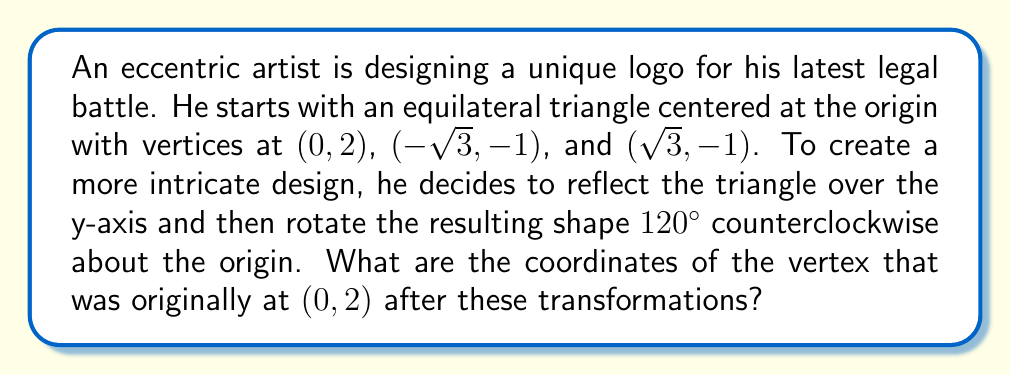Teach me how to tackle this problem. Let's approach this step-by-step:

1) First, we reflect the triangle over the y-axis:
   The point $(0, 2)$ remains unchanged as it's on the y-axis.
   $(-\sqrt{3}, -1)$ becomes $(\sqrt{3}, -1)$
   $(\sqrt{3}, -1)$ becomes $(-\sqrt{3}, -1)$

2) Now we have a new triangle with vertices at $(0, 2)$, $(\sqrt{3}, -1)$, and $(-\sqrt{3}, -1)$.

3) Next, we rotate this new shape 120° counterclockwise about the origin.
   To rotate a point $(x, y)$ by an angle $\theta$ counterclockwise, we use the transformation:
   $$(x', y') = (x\cos\theta - y\sin\theta, x\sin\theta + y\cos\theta)$$

4) For a 120° rotation, $\cos 120° = -\frac{1}{2}$ and $\sin 120° = \frac{\sqrt{3}}{2}$

5) Applying this to the point $(0, 2)$:
   $$\begin{align}
   x' &= 0 \cdot (-\frac{1}{2}) - 2 \cdot \frac{\sqrt{3}}{2} = -\sqrt{3} \\
   y' &= 0 \cdot \frac{\sqrt{3}}{2} + 2 \cdot (-\frac{1}{2}) = -1
   \end{align}$$

Therefore, after both transformations, the point originally at $(0, 2)$ is now at $(-\sqrt{3}, -1)$.
Answer: $(-\sqrt{3}, -1)$ 